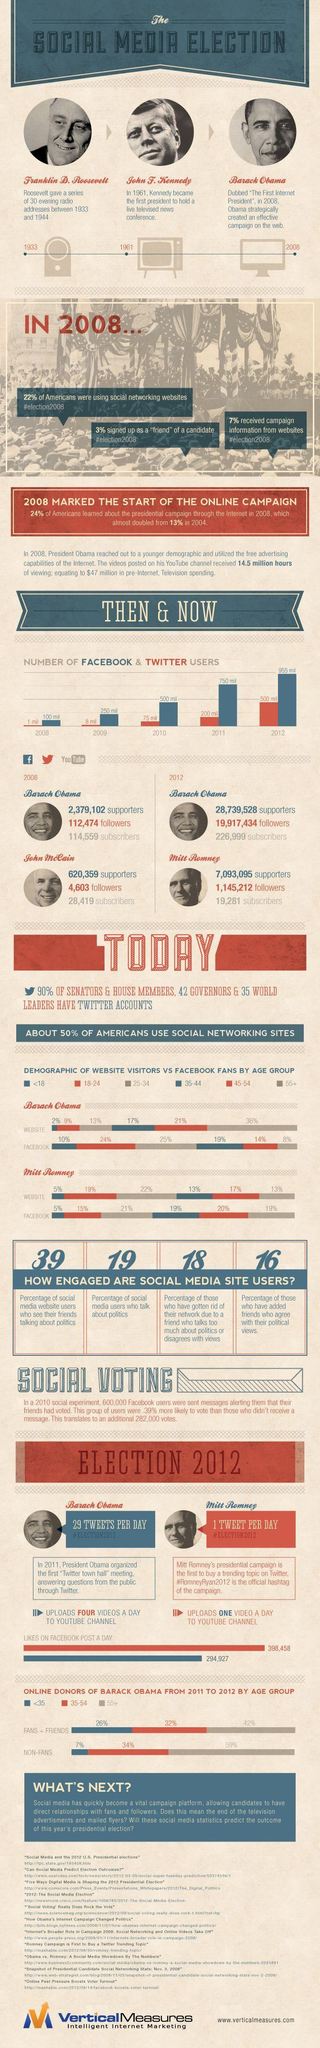What was the growth in the number of Twitter users during the first year ?
Answer the question with a short phrase. 7 million Which year marked the beginning of election campaigning using radios, 2008, 1961, or 1933? 1933 What was the increase number of followers Obama had in Twitter in 2012? 19,804,960 What percentage of website visitors for Barack Obama were aged between 45-54? 21% What percentage of Facebook fans of Mitt Romney were aged between 35-44 and 55+? 19% What percentage of users have given up social media cause they disagree with other political views? 18 Which year saw an increase in FB users to twice the number of 2009? 2010 What was the medium of election campaign used by President Kennedy for elections, TV, Radio, or Internet? TV What is the age group of the non-fans of Barack Obama who contributed to being the highest percentage of online donors ? 55+ What was the increase number of subscribers Obama had on YouTube in 2012? 112,440 